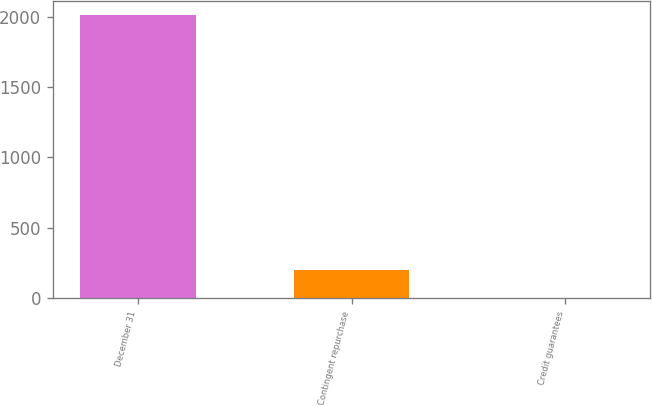Convert chart. <chart><loc_0><loc_0><loc_500><loc_500><bar_chart><fcel>December 31<fcel>Contingent repurchase<fcel>Credit guarantees<nl><fcel>2013<fcel>203.1<fcel>2<nl></chart> 